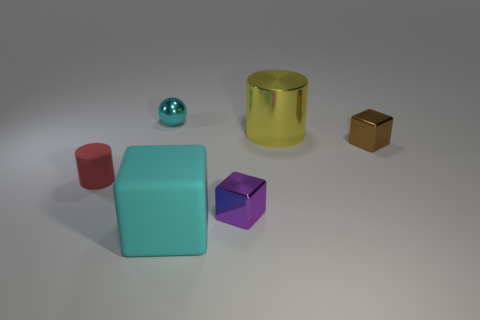How many other things are the same size as the sphere?
Keep it short and to the point. 3. What size is the metal thing left of the large rubber cube?
Provide a short and direct response. Small. What is the shape of the purple thing that is made of the same material as the large cylinder?
Offer a very short reply. Cube. Is there anything else that is the same color as the small metal ball?
Your response must be concise. Yes. The tiny object on the left side of the cyan thing behind the cyan rubber cube is what color?
Your response must be concise. Red. How many large objects are either gray rubber cylinders or yellow things?
Your answer should be compact. 1. What is the material of the large cyan thing that is the same shape as the tiny purple metallic object?
Give a very brief answer. Rubber. The shiny sphere has what color?
Give a very brief answer. Cyan. Is the color of the metal sphere the same as the matte cube?
Keep it short and to the point. Yes. How many purple metallic things are to the right of the tiny cyan object that is on the left side of the tiny purple metallic block?
Ensure brevity in your answer.  1. 